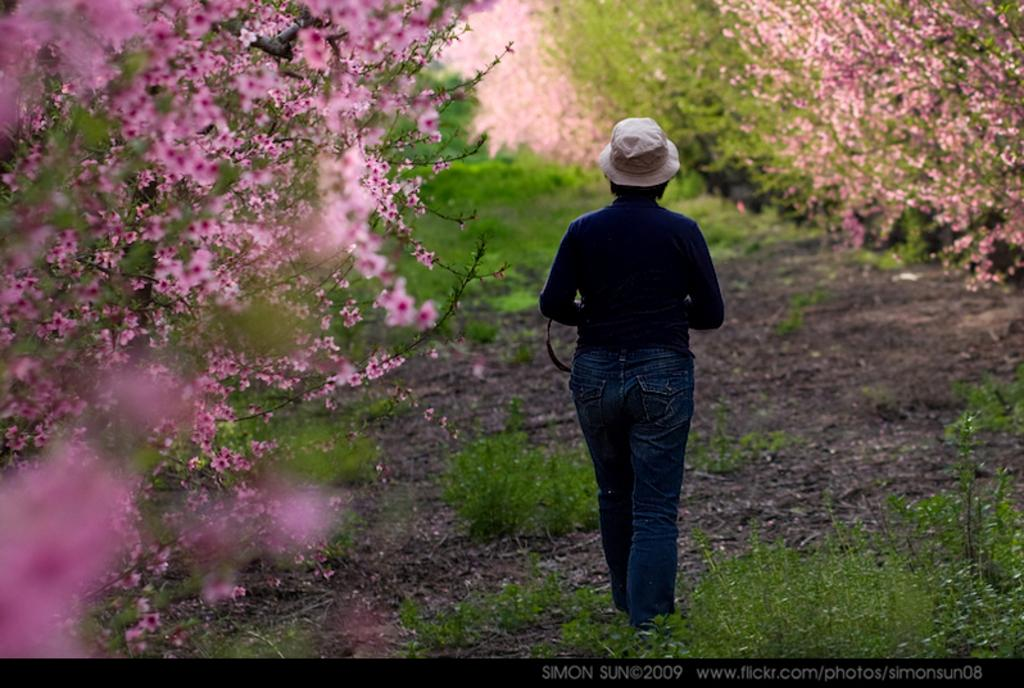What is the person in the image doing? There is a person walking in the image. What is the person wearing on their head? The person is wearing a hat. What type of vegetation can be seen in the image? There are plants, trees, and flowers in the image. What type of curtain can be seen hanging from the sheet in the image? There is no sheet or curtain present in the image. What type of plate is being used to serve the flowers in the image? There is no plate visible in the image, and the flowers are not being served; they are growing in the ground. 